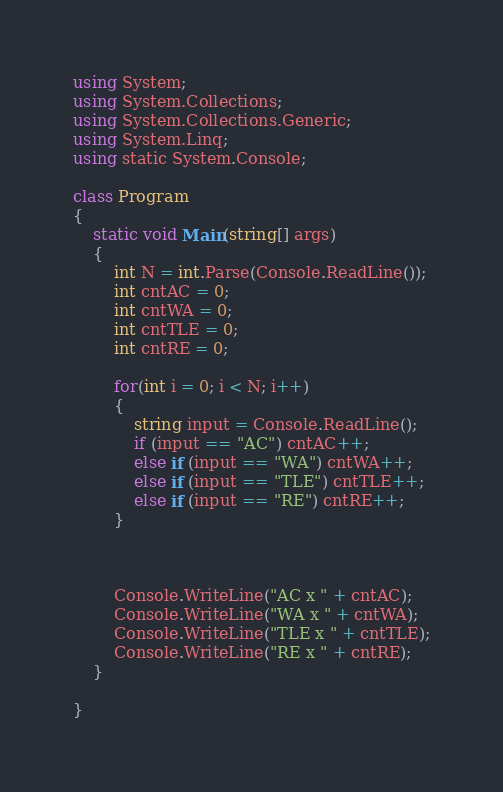<code> <loc_0><loc_0><loc_500><loc_500><_C#_>using System;
using System.Collections;
using System.Collections.Generic;
using System.Linq;
using static System.Console;

class Program
{
    static void Main(string[] args)
    {
        int N = int.Parse(Console.ReadLine());
        int cntAC = 0;
        int cntWA = 0;
        int cntTLE = 0;
        int cntRE = 0;

        for(int i = 0; i < N; i++)
        {
            string input = Console.ReadLine();
            if (input == "AC") cntAC++;
            else if (input == "WA") cntWA++;
            else if (input == "TLE") cntTLE++;
            else if (input == "RE") cntRE++;
        }



        Console.WriteLine("AC x " + cntAC);
        Console.WriteLine("WA x " + cntWA);
        Console.WriteLine("TLE x " + cntTLE);
        Console.WriteLine("RE x " + cntRE);
    }

}

</code> 